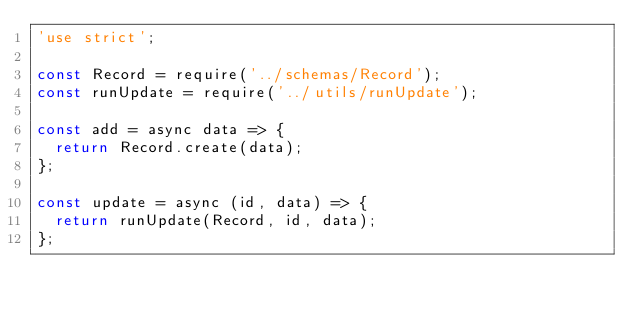<code> <loc_0><loc_0><loc_500><loc_500><_JavaScript_>'use strict';

const Record = require('../schemas/Record');
const runUpdate = require('../utils/runUpdate');

const add = async data => {
  return Record.create(data);
};

const update = async (id, data) => {
  return runUpdate(Record, id, data);
};
</code> 